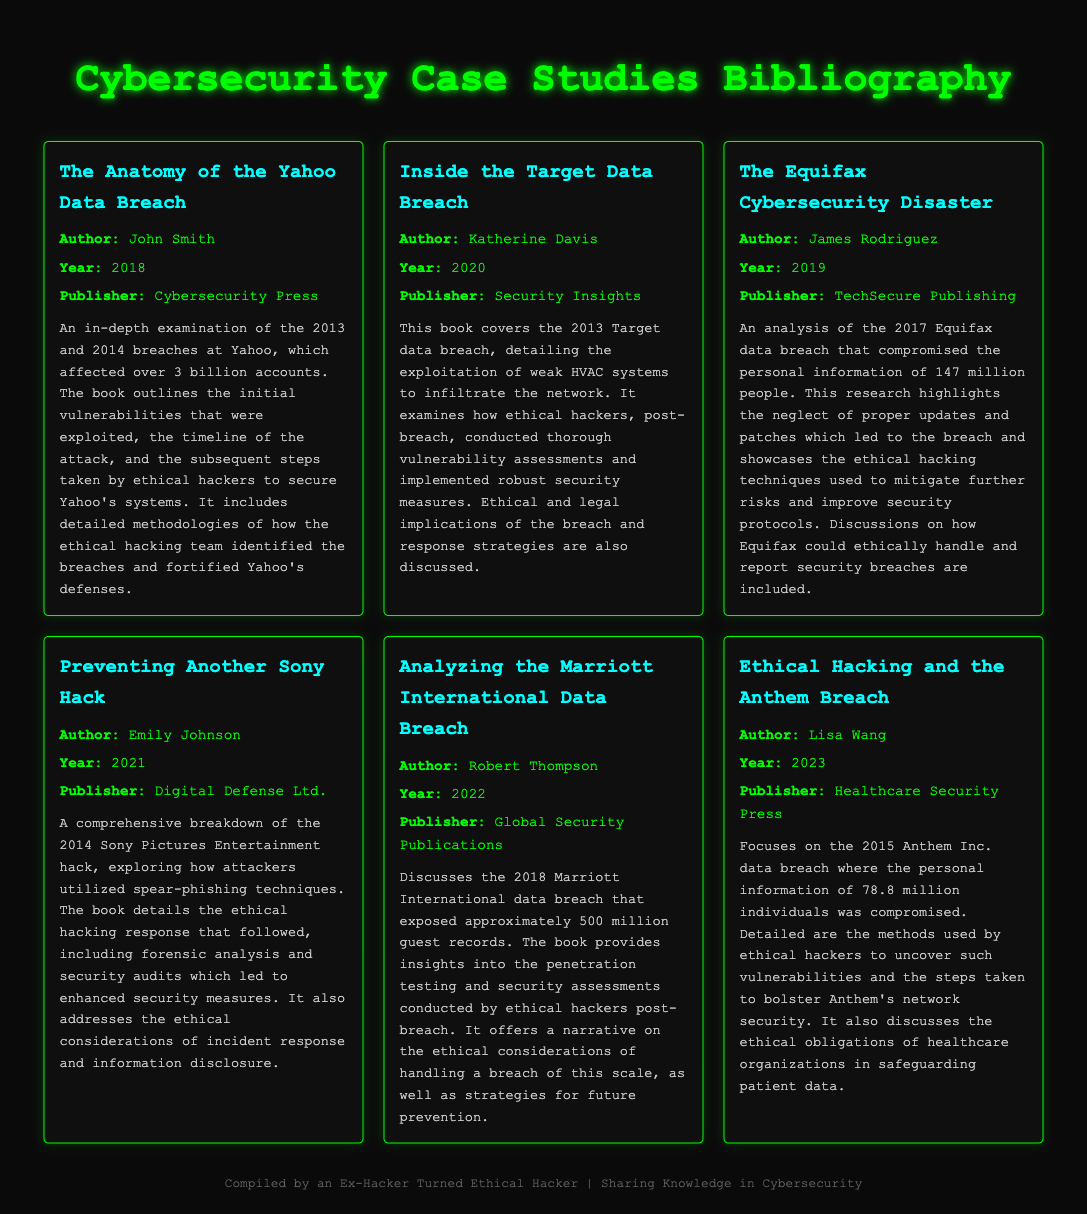What is the title of the case study by John Smith? The title given in the document under John Smith is "The Anatomy of the Yahoo Data Breach."
Answer: The Anatomy of the Yahoo Data Breach In what year was "Inside the Target Data Breach" published? The document mentions that "Inside the Target Data Breach" was published in 2020.
Answer: 2020 How many accounts were affected by the Yahoo data breach? The document indicates that the Yahoo data breach affected over 3 billion accounts.
Answer: Over 3 billion Who authored the case study focused on the Anthem breach? Lisa Wang is listed as the author for the case study on the Anthem breach.
Answer: Lisa Wang What ethical concern is discussed in relation to the Equifax data breach? The document states that discussions on how Equifax could ethically handle and report security breaches are included.
Answer: Ethical handling and reporting Which publisher released the study on the Marriott International data breach? The publisher for the Marriott International data breach study is Global Security Publications, as provided in the document.
Answer: Global Security Publications What technique was primarily used to attack Sony Pictures Entertainment? The document specifies that spear-phishing techniques were utilized in the attack on Sony Pictures Entertainment.
Answer: Spear-phishing techniques How many individuals' information was compromised in the Anthem data breach? The document notes that the personal information of 78.8 million individuals was compromised in the Anthem breach.
Answer: 78.8 million 